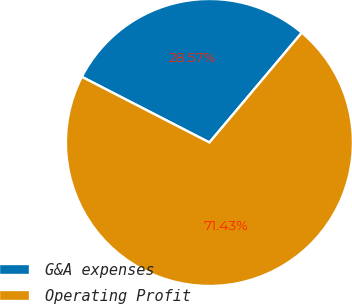Convert chart to OTSL. <chart><loc_0><loc_0><loc_500><loc_500><pie_chart><fcel>G&A expenses<fcel>Operating Profit<nl><fcel>28.57%<fcel>71.43%<nl></chart> 